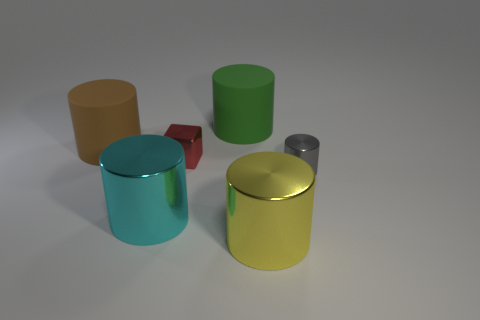Subtract all brown cylinders. How many cylinders are left? 4 Subtract all cyan cylinders. How many cylinders are left? 4 Subtract all cyan cylinders. Subtract all red cubes. How many cylinders are left? 4 Add 4 small red metallic cylinders. How many objects exist? 10 Subtract all cylinders. How many objects are left? 1 Add 6 big yellow objects. How many big yellow objects are left? 7 Add 2 brown balls. How many brown balls exist? 2 Subtract 0 brown spheres. How many objects are left? 6 Subtract all big cyan shiny cylinders. Subtract all large yellow metal cylinders. How many objects are left? 4 